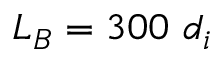<formula> <loc_0><loc_0><loc_500><loc_500>L _ { B } = 3 0 0 \ d _ { i }</formula> 